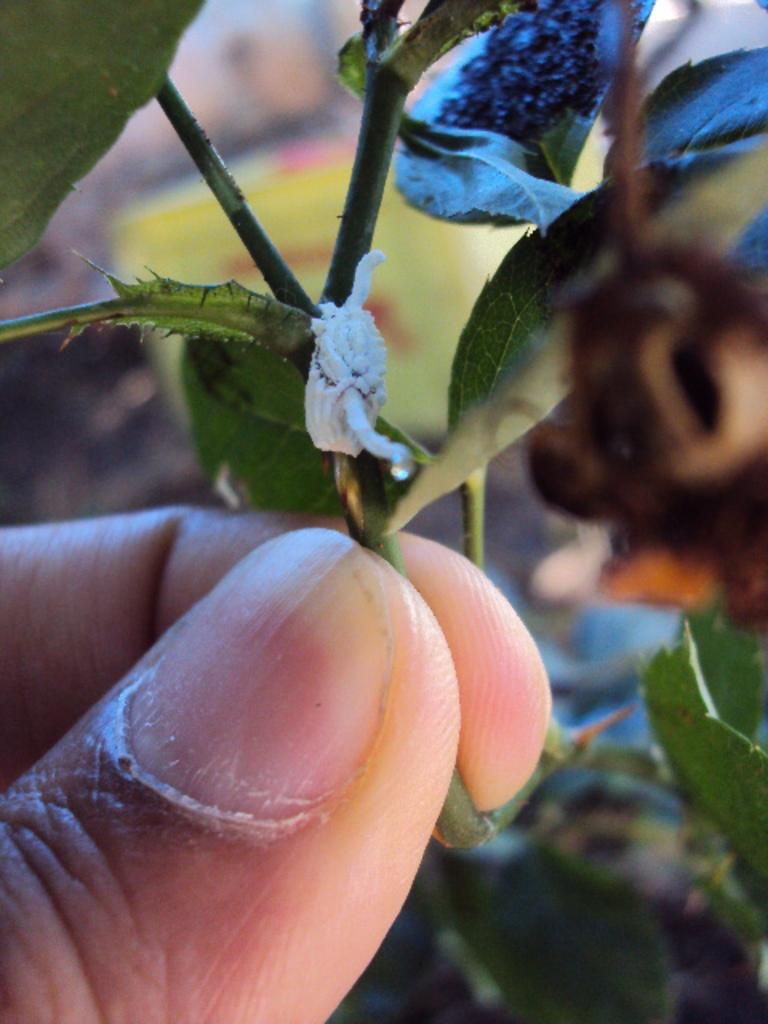What is being held in the image? There is a person's fingers holding a plant in the image. Can you describe the plant being held? Unfortunately, the specific type of plant cannot be determined from the image. What part of the person is visible in the image? Only the person's fingers are visible in the image. What type of game is being played in the image? There is no game being played in the image; it only shows a person's fingers holding a plant. How comfortable is the person in the image? The comfort level of the person cannot be determined from the image, as only their fingers are visible. 